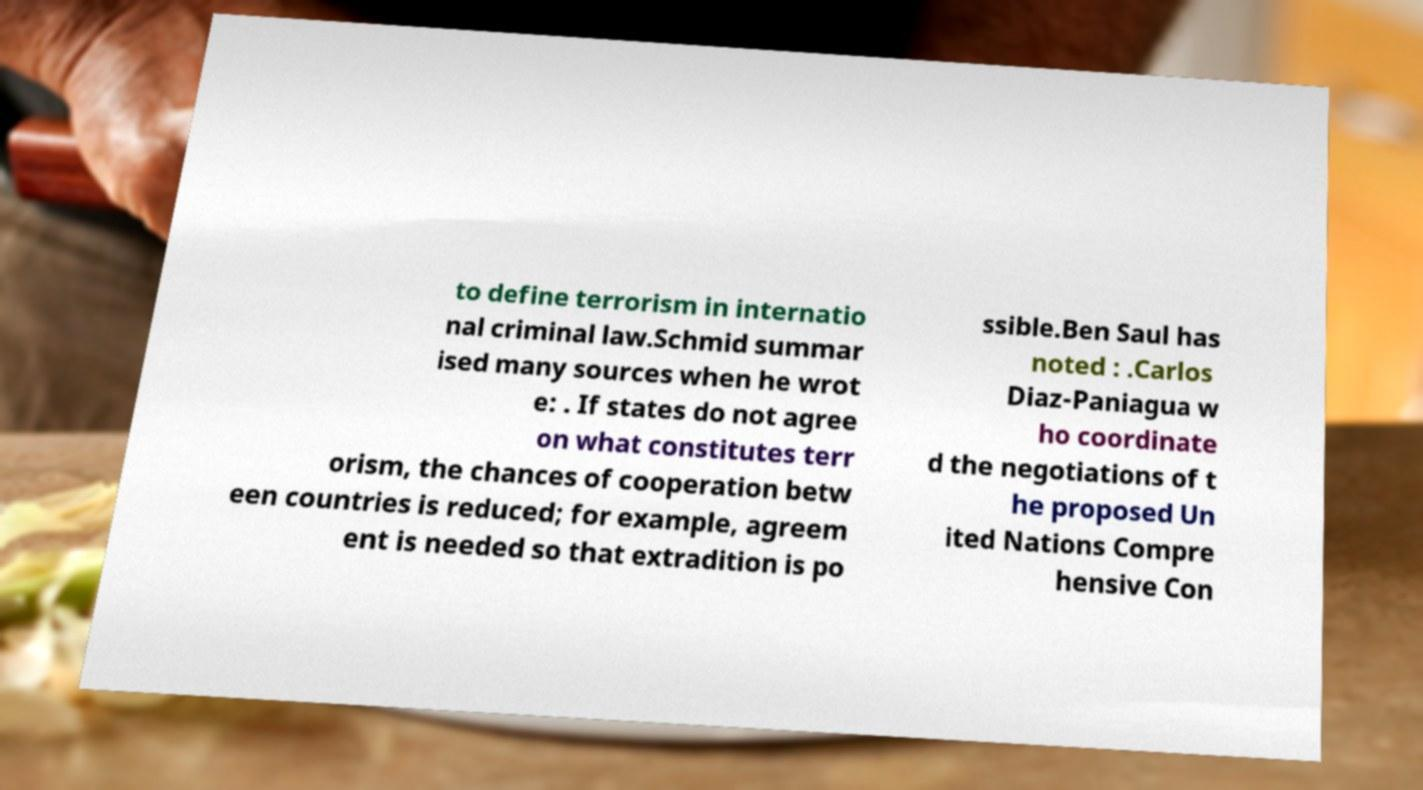For documentation purposes, I need the text within this image transcribed. Could you provide that? to define terrorism in internatio nal criminal law.Schmid summar ised many sources when he wrot e: . If states do not agree on what constitutes terr orism, the chances of cooperation betw een countries is reduced; for example, agreem ent is needed so that extradition is po ssible.Ben Saul has noted : .Carlos Diaz-Paniagua w ho coordinate d the negotiations of t he proposed Un ited Nations Compre hensive Con 